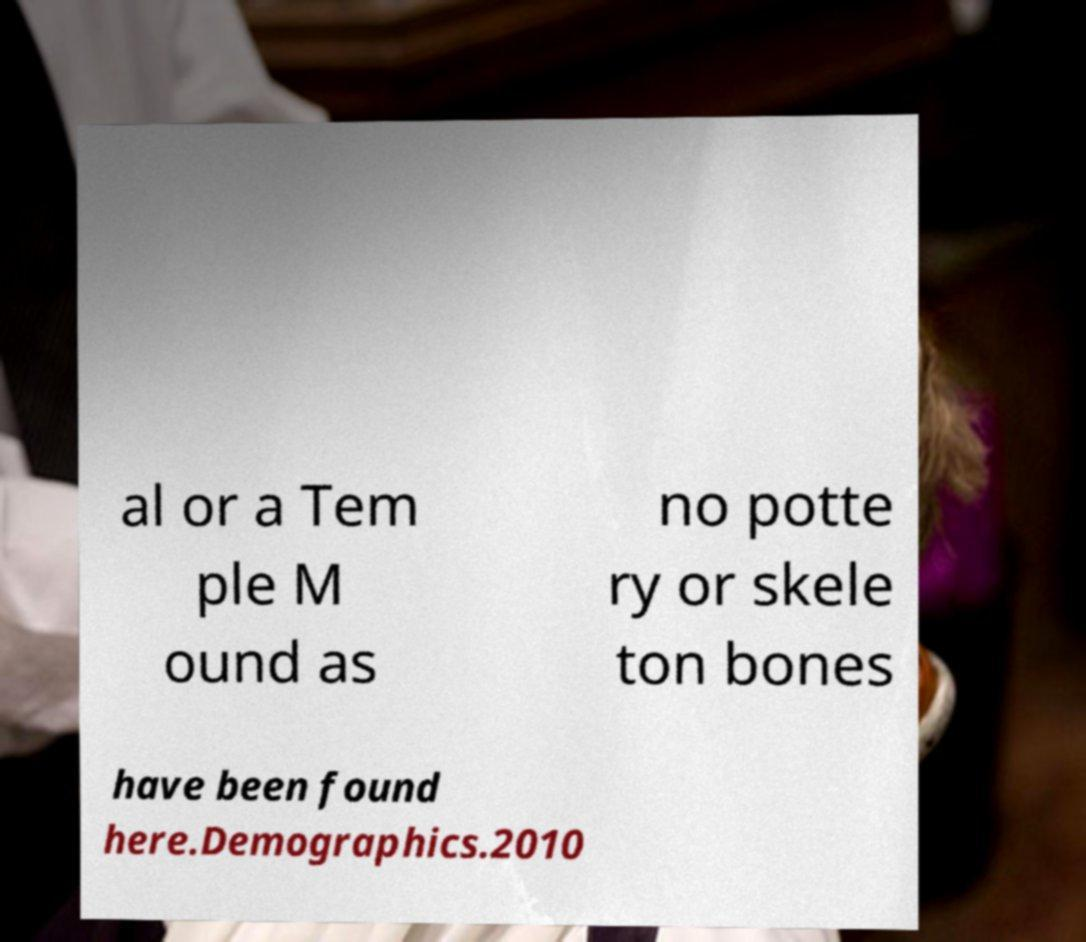Could you assist in decoding the text presented in this image and type it out clearly? al or a Tem ple M ound as no potte ry or skele ton bones have been found here.Demographics.2010 